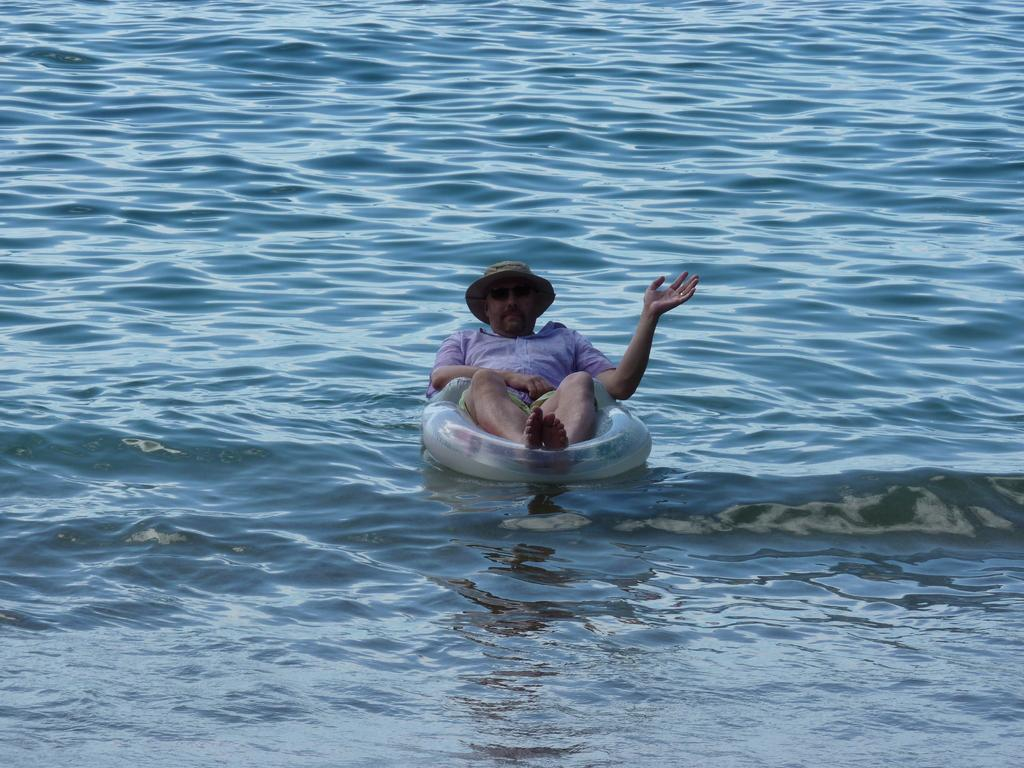Who or what is in the image? There is a person in the image. What is the person doing in the image? The person is sitting on an inner tube. Where is the person located in the image? The person is on the water. What is the person wearing on their head in the image? The person is wearing a hat. What type of yak can be seen in the image? There is no yak present in the image; it features a person sitting on an inner tube on the water. What organization is responsible for the person's presence in the image? There is no organization mentioned or implied in the image, as it simply shows a person sitting on an inner tube on the water. 